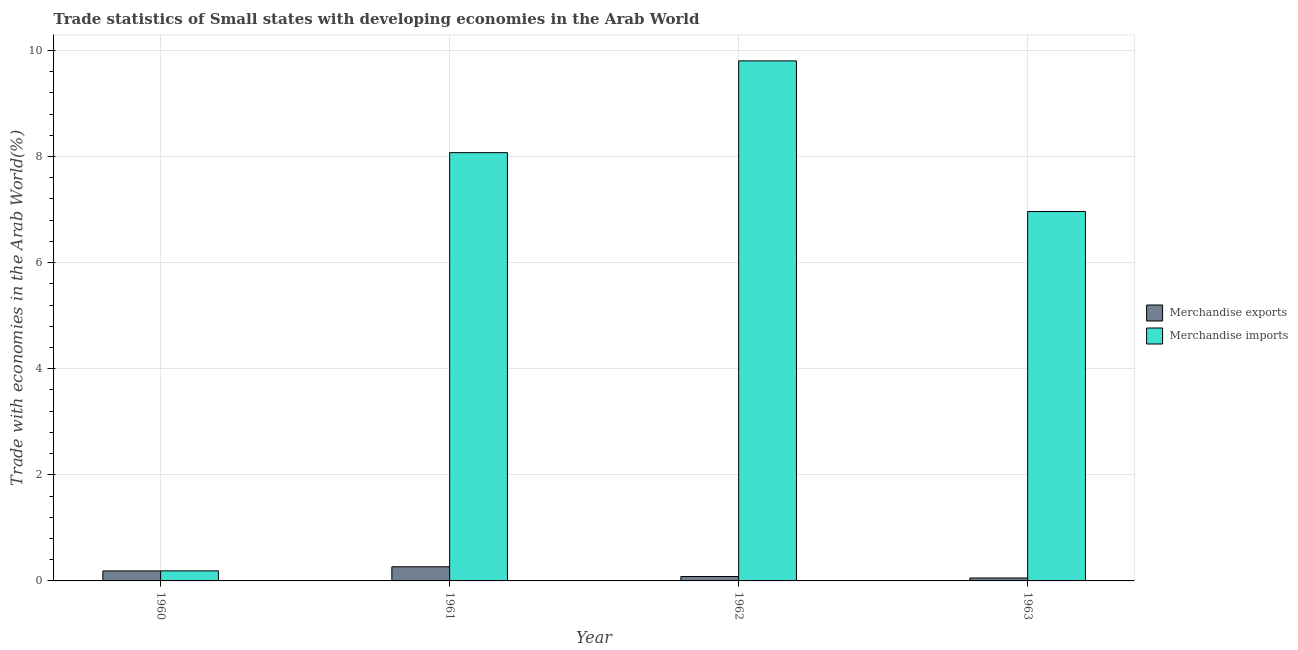Are the number of bars on each tick of the X-axis equal?
Ensure brevity in your answer.  Yes. In how many cases, is the number of bars for a given year not equal to the number of legend labels?
Your answer should be very brief. 0. What is the merchandise exports in 1962?
Offer a terse response. 0.08. Across all years, what is the maximum merchandise imports?
Your answer should be very brief. 9.8. Across all years, what is the minimum merchandise imports?
Make the answer very short. 0.19. In which year was the merchandise exports minimum?
Ensure brevity in your answer.  1963. What is the total merchandise imports in the graph?
Provide a succinct answer. 25.03. What is the difference between the merchandise exports in 1961 and that in 1963?
Your response must be concise. 0.21. What is the difference between the merchandise exports in 1963 and the merchandise imports in 1962?
Offer a very short reply. -0.03. What is the average merchandise exports per year?
Give a very brief answer. 0.15. In how many years, is the merchandise exports greater than 2.8 %?
Your response must be concise. 0. What is the ratio of the merchandise imports in 1960 to that in 1963?
Your answer should be compact. 0.03. Is the merchandise exports in 1960 less than that in 1963?
Make the answer very short. No. What is the difference between the highest and the second highest merchandise exports?
Offer a terse response. 0.08. What is the difference between the highest and the lowest merchandise imports?
Provide a succinct answer. 9.61. In how many years, is the merchandise exports greater than the average merchandise exports taken over all years?
Your answer should be compact. 2. Is the sum of the merchandise exports in 1960 and 1962 greater than the maximum merchandise imports across all years?
Ensure brevity in your answer.  Yes. What does the 2nd bar from the right in 1961 represents?
Provide a succinct answer. Merchandise exports. Are all the bars in the graph horizontal?
Offer a terse response. No. Are the values on the major ticks of Y-axis written in scientific E-notation?
Offer a terse response. No. Does the graph contain grids?
Provide a succinct answer. Yes. Where does the legend appear in the graph?
Provide a succinct answer. Center right. What is the title of the graph?
Provide a succinct answer. Trade statistics of Small states with developing economies in the Arab World. Does "Overweight" appear as one of the legend labels in the graph?
Your response must be concise. No. What is the label or title of the X-axis?
Ensure brevity in your answer.  Year. What is the label or title of the Y-axis?
Offer a terse response. Trade with economies in the Arab World(%). What is the Trade with economies in the Arab World(%) in Merchandise exports in 1960?
Your response must be concise. 0.19. What is the Trade with economies in the Arab World(%) in Merchandise imports in 1960?
Your answer should be very brief. 0.19. What is the Trade with economies in the Arab World(%) in Merchandise exports in 1961?
Make the answer very short. 0.27. What is the Trade with economies in the Arab World(%) in Merchandise imports in 1961?
Give a very brief answer. 8.07. What is the Trade with economies in the Arab World(%) of Merchandise exports in 1962?
Provide a short and direct response. 0.08. What is the Trade with economies in the Arab World(%) of Merchandise imports in 1962?
Make the answer very short. 9.8. What is the Trade with economies in the Arab World(%) in Merchandise exports in 1963?
Make the answer very short. 0.06. What is the Trade with economies in the Arab World(%) in Merchandise imports in 1963?
Make the answer very short. 6.96. Across all years, what is the maximum Trade with economies in the Arab World(%) of Merchandise exports?
Offer a terse response. 0.27. Across all years, what is the maximum Trade with economies in the Arab World(%) of Merchandise imports?
Your answer should be compact. 9.8. Across all years, what is the minimum Trade with economies in the Arab World(%) in Merchandise exports?
Offer a very short reply. 0.06. Across all years, what is the minimum Trade with economies in the Arab World(%) in Merchandise imports?
Make the answer very short. 0.19. What is the total Trade with economies in the Arab World(%) of Merchandise exports in the graph?
Ensure brevity in your answer.  0.59. What is the total Trade with economies in the Arab World(%) in Merchandise imports in the graph?
Your answer should be very brief. 25.03. What is the difference between the Trade with economies in the Arab World(%) in Merchandise exports in 1960 and that in 1961?
Make the answer very short. -0.08. What is the difference between the Trade with economies in the Arab World(%) in Merchandise imports in 1960 and that in 1961?
Provide a succinct answer. -7.88. What is the difference between the Trade with economies in the Arab World(%) in Merchandise exports in 1960 and that in 1962?
Provide a succinct answer. 0.11. What is the difference between the Trade with economies in the Arab World(%) in Merchandise imports in 1960 and that in 1962?
Your answer should be very brief. -9.61. What is the difference between the Trade with economies in the Arab World(%) of Merchandise exports in 1960 and that in 1963?
Give a very brief answer. 0.13. What is the difference between the Trade with economies in the Arab World(%) in Merchandise imports in 1960 and that in 1963?
Keep it short and to the point. -6.77. What is the difference between the Trade with economies in the Arab World(%) of Merchandise exports in 1961 and that in 1962?
Offer a very short reply. 0.18. What is the difference between the Trade with economies in the Arab World(%) of Merchandise imports in 1961 and that in 1962?
Offer a very short reply. -1.73. What is the difference between the Trade with economies in the Arab World(%) in Merchandise exports in 1961 and that in 1963?
Offer a terse response. 0.21. What is the difference between the Trade with economies in the Arab World(%) in Merchandise imports in 1961 and that in 1963?
Give a very brief answer. 1.11. What is the difference between the Trade with economies in the Arab World(%) in Merchandise exports in 1962 and that in 1963?
Offer a very short reply. 0.03. What is the difference between the Trade with economies in the Arab World(%) of Merchandise imports in 1962 and that in 1963?
Offer a very short reply. 2.84. What is the difference between the Trade with economies in the Arab World(%) of Merchandise exports in 1960 and the Trade with economies in the Arab World(%) of Merchandise imports in 1961?
Offer a very short reply. -7.88. What is the difference between the Trade with economies in the Arab World(%) in Merchandise exports in 1960 and the Trade with economies in the Arab World(%) in Merchandise imports in 1962?
Make the answer very short. -9.61. What is the difference between the Trade with economies in the Arab World(%) of Merchandise exports in 1960 and the Trade with economies in the Arab World(%) of Merchandise imports in 1963?
Offer a terse response. -6.77. What is the difference between the Trade with economies in the Arab World(%) in Merchandise exports in 1961 and the Trade with economies in the Arab World(%) in Merchandise imports in 1962?
Provide a short and direct response. -9.54. What is the difference between the Trade with economies in the Arab World(%) of Merchandise exports in 1961 and the Trade with economies in the Arab World(%) of Merchandise imports in 1963?
Your answer should be very brief. -6.7. What is the difference between the Trade with economies in the Arab World(%) in Merchandise exports in 1962 and the Trade with economies in the Arab World(%) in Merchandise imports in 1963?
Give a very brief answer. -6.88. What is the average Trade with economies in the Arab World(%) in Merchandise exports per year?
Offer a terse response. 0.15. What is the average Trade with economies in the Arab World(%) in Merchandise imports per year?
Keep it short and to the point. 6.26. In the year 1960, what is the difference between the Trade with economies in the Arab World(%) of Merchandise exports and Trade with economies in the Arab World(%) of Merchandise imports?
Your response must be concise. -0. In the year 1961, what is the difference between the Trade with economies in the Arab World(%) in Merchandise exports and Trade with economies in the Arab World(%) in Merchandise imports?
Ensure brevity in your answer.  -7.81. In the year 1962, what is the difference between the Trade with economies in the Arab World(%) in Merchandise exports and Trade with economies in the Arab World(%) in Merchandise imports?
Make the answer very short. -9.72. In the year 1963, what is the difference between the Trade with economies in the Arab World(%) in Merchandise exports and Trade with economies in the Arab World(%) in Merchandise imports?
Keep it short and to the point. -6.91. What is the ratio of the Trade with economies in the Arab World(%) of Merchandise exports in 1960 to that in 1961?
Make the answer very short. 0.71. What is the ratio of the Trade with economies in the Arab World(%) in Merchandise imports in 1960 to that in 1961?
Make the answer very short. 0.02. What is the ratio of the Trade with economies in the Arab World(%) of Merchandise exports in 1960 to that in 1962?
Offer a very short reply. 2.26. What is the ratio of the Trade with economies in the Arab World(%) of Merchandise imports in 1960 to that in 1962?
Give a very brief answer. 0.02. What is the ratio of the Trade with economies in the Arab World(%) of Merchandise exports in 1960 to that in 1963?
Provide a short and direct response. 3.41. What is the ratio of the Trade with economies in the Arab World(%) in Merchandise imports in 1960 to that in 1963?
Provide a short and direct response. 0.03. What is the ratio of the Trade with economies in the Arab World(%) of Merchandise exports in 1961 to that in 1962?
Offer a very short reply. 3.2. What is the ratio of the Trade with economies in the Arab World(%) of Merchandise imports in 1961 to that in 1962?
Keep it short and to the point. 0.82. What is the ratio of the Trade with economies in the Arab World(%) of Merchandise exports in 1961 to that in 1963?
Your response must be concise. 4.83. What is the ratio of the Trade with economies in the Arab World(%) of Merchandise imports in 1961 to that in 1963?
Provide a succinct answer. 1.16. What is the ratio of the Trade with economies in the Arab World(%) of Merchandise exports in 1962 to that in 1963?
Provide a short and direct response. 1.51. What is the ratio of the Trade with economies in the Arab World(%) in Merchandise imports in 1962 to that in 1963?
Ensure brevity in your answer.  1.41. What is the difference between the highest and the second highest Trade with economies in the Arab World(%) in Merchandise exports?
Offer a very short reply. 0.08. What is the difference between the highest and the second highest Trade with economies in the Arab World(%) in Merchandise imports?
Give a very brief answer. 1.73. What is the difference between the highest and the lowest Trade with economies in the Arab World(%) in Merchandise exports?
Provide a succinct answer. 0.21. What is the difference between the highest and the lowest Trade with economies in the Arab World(%) of Merchandise imports?
Your response must be concise. 9.61. 